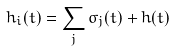<formula> <loc_0><loc_0><loc_500><loc_500>h _ { i } ( t ) = \sum _ { j } \sigma _ { j } ( t ) + h ( t )</formula> 